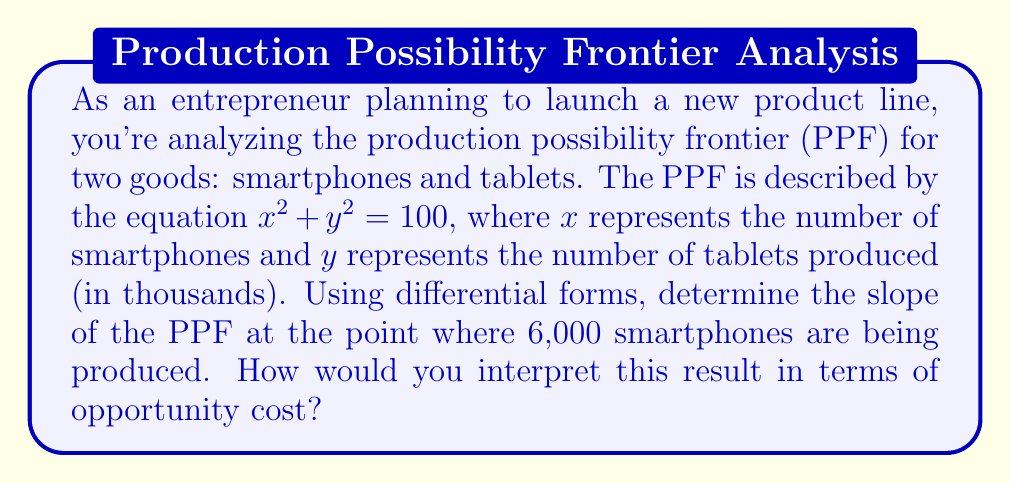Help me with this question. Let's approach this step-by-step:

1) The PPF is given by the equation $x^2 + y^2 = 100$. This is a circle with radius 10 in the first quadrant.

2) To find the slope at any point, we need to implicitly differentiate the equation:
   $$2x dx + 2y dy = 0$$
   $$\frac{dy}{dx} = -\frac{x}{y}$$

3) We're asked to find the slope when 6,000 smartphones are produced, so $x = 6$.

4) To find the corresponding $y$ value, we substitute $x = 6$ into the original equation:
   $$6^2 + y^2 = 100$$
   $$36 + y^2 = 100$$
   $$y^2 = 64$$
   $$y = 8$$ (we take the positive root as production can't be negative)

5) Now we can calculate the slope:
   $$\frac{dy}{dx} = -\frac{x}{y} = -\frac{6}{8} = -\frac{3}{4}$$

6) Interpretation: The slope of -3/4 means that at this point, to produce one more smartphone, we would need to decrease tablet production by 3/4 of a unit. This represents the opportunity cost of producing an additional smartphone in terms of tablets foregone.

7) For an entrepreneur, this information is crucial for decision-making. It shows that at this production level, the trade-off between smartphones and tablets is 1:0.75, which can help in determining the most efficient allocation of resources based on market demand and profit margins for each product.
Answer: $-\frac{3}{4}$ 